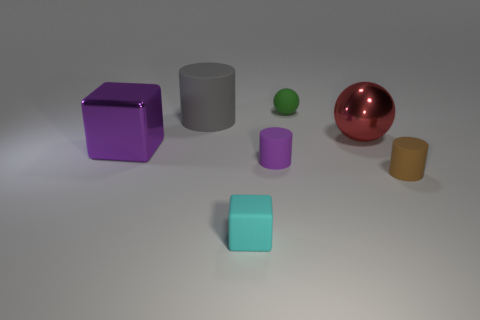Add 2 large brown cylinders. How many objects exist? 9 Subtract all balls. How many objects are left? 5 Add 2 large brown matte balls. How many large brown matte balls exist? 2 Subtract 0 blue cylinders. How many objects are left? 7 Subtract all blue metallic spheres. Subtract all cyan things. How many objects are left? 6 Add 3 tiny green things. How many tiny green things are left? 4 